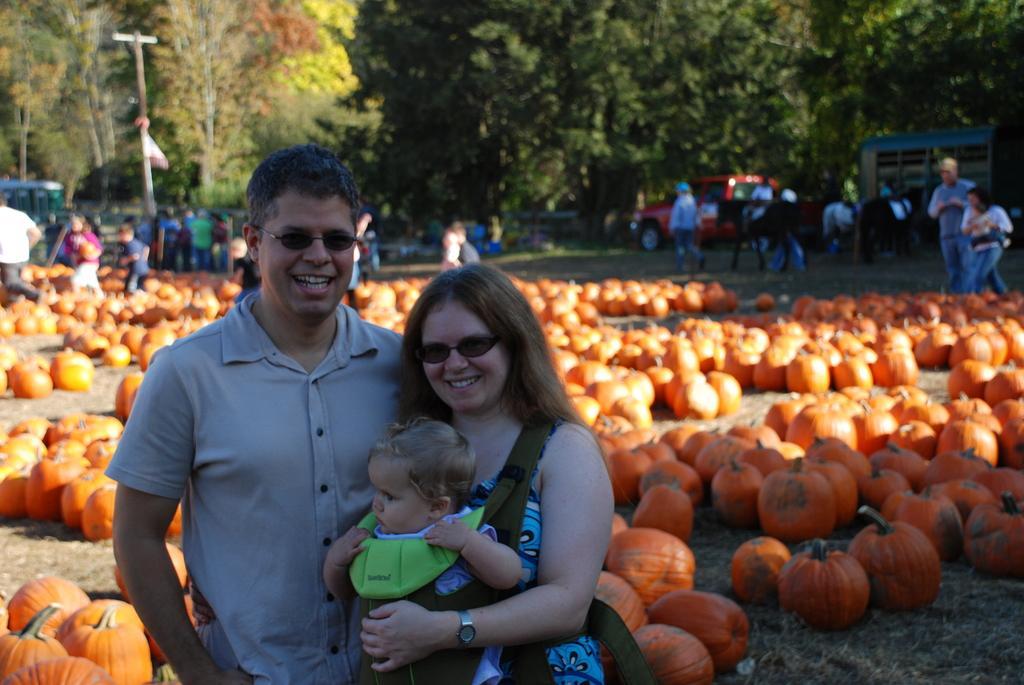Could you give a brief overview of what you see in this image? In this picture we can see so many fruits are placed in a ground, around so many people are standing and taking pictures. 